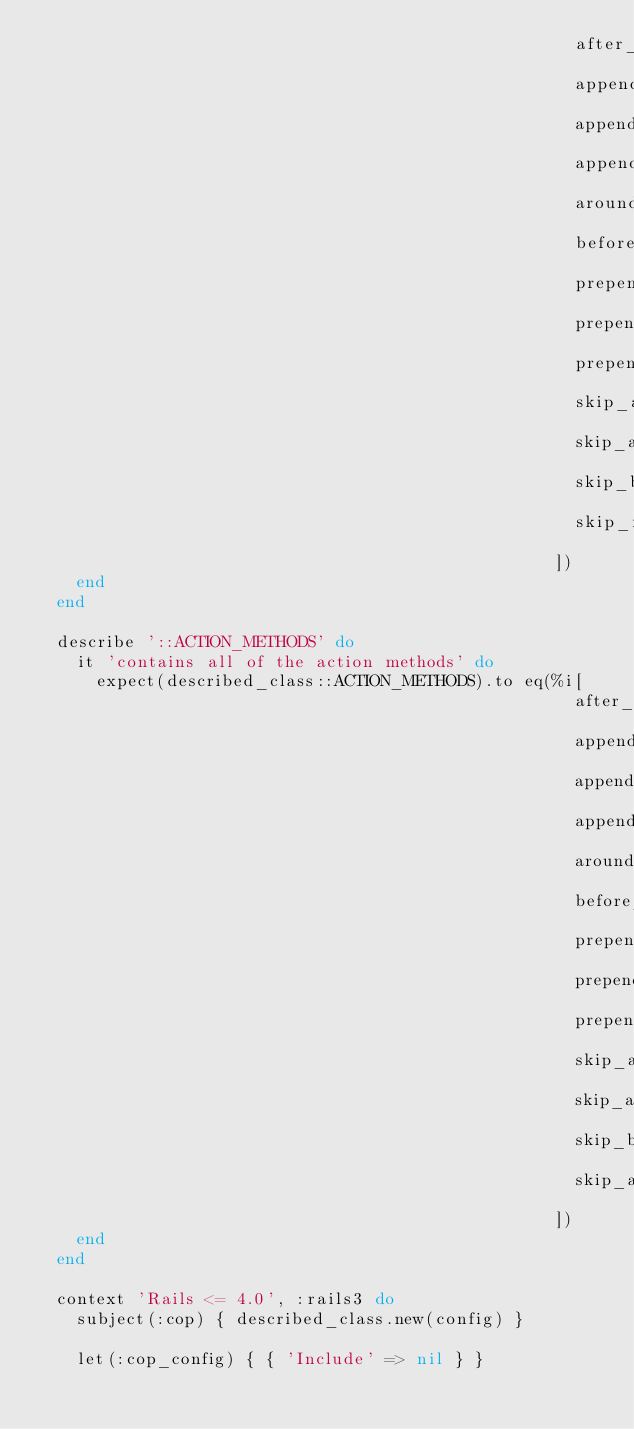Convert code to text. <code><loc_0><loc_0><loc_500><loc_500><_Ruby_>                                                      after_filter
                                                      append_after_filter
                                                      append_around_filter
                                                      append_before_filter
                                                      around_filter
                                                      before_filter
                                                      prepend_after_filter
                                                      prepend_around_filter
                                                      prepend_before_filter
                                                      skip_after_filter
                                                      skip_around_filter
                                                      skip_before_filter
                                                      skip_filter
                                                    ])
    end
  end

  describe '::ACTION_METHODS' do
    it 'contains all of the action methods' do
      expect(described_class::ACTION_METHODS).to eq(%i[
                                                      after_action
                                                      append_after_action
                                                      append_around_action
                                                      append_before_action
                                                      around_action
                                                      before_action
                                                      prepend_after_action
                                                      prepend_around_action
                                                      prepend_before_action
                                                      skip_after_action
                                                      skip_around_action
                                                      skip_before_action
                                                      skip_action_callback
                                                    ])
    end
  end

  context 'Rails <= 4.0', :rails3 do
    subject(:cop) { described_class.new(config) }

    let(:cop_config) { { 'Include' => nil } }
</code> 